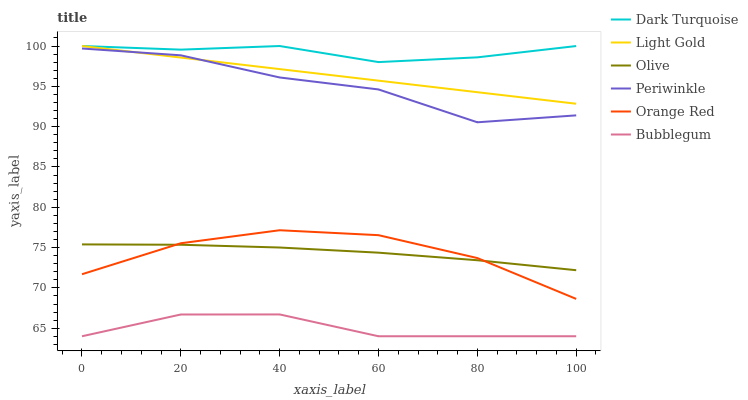Does Bubblegum have the minimum area under the curve?
Answer yes or no. Yes. Does Dark Turquoise have the maximum area under the curve?
Answer yes or no. Yes. Does Periwinkle have the minimum area under the curve?
Answer yes or no. No. Does Periwinkle have the maximum area under the curve?
Answer yes or no. No. Is Light Gold the smoothest?
Answer yes or no. Yes. Is Periwinkle the roughest?
Answer yes or no. Yes. Is Bubblegum the smoothest?
Answer yes or no. No. Is Bubblegum the roughest?
Answer yes or no. No. Does Periwinkle have the lowest value?
Answer yes or no. No. Does Light Gold have the highest value?
Answer yes or no. Yes. Does Periwinkle have the highest value?
Answer yes or no. No. Is Olive less than Periwinkle?
Answer yes or no. Yes. Is Dark Turquoise greater than Orange Red?
Answer yes or no. Yes. Does Dark Turquoise intersect Light Gold?
Answer yes or no. Yes. Is Dark Turquoise less than Light Gold?
Answer yes or no. No. Is Dark Turquoise greater than Light Gold?
Answer yes or no. No. Does Olive intersect Periwinkle?
Answer yes or no. No. 